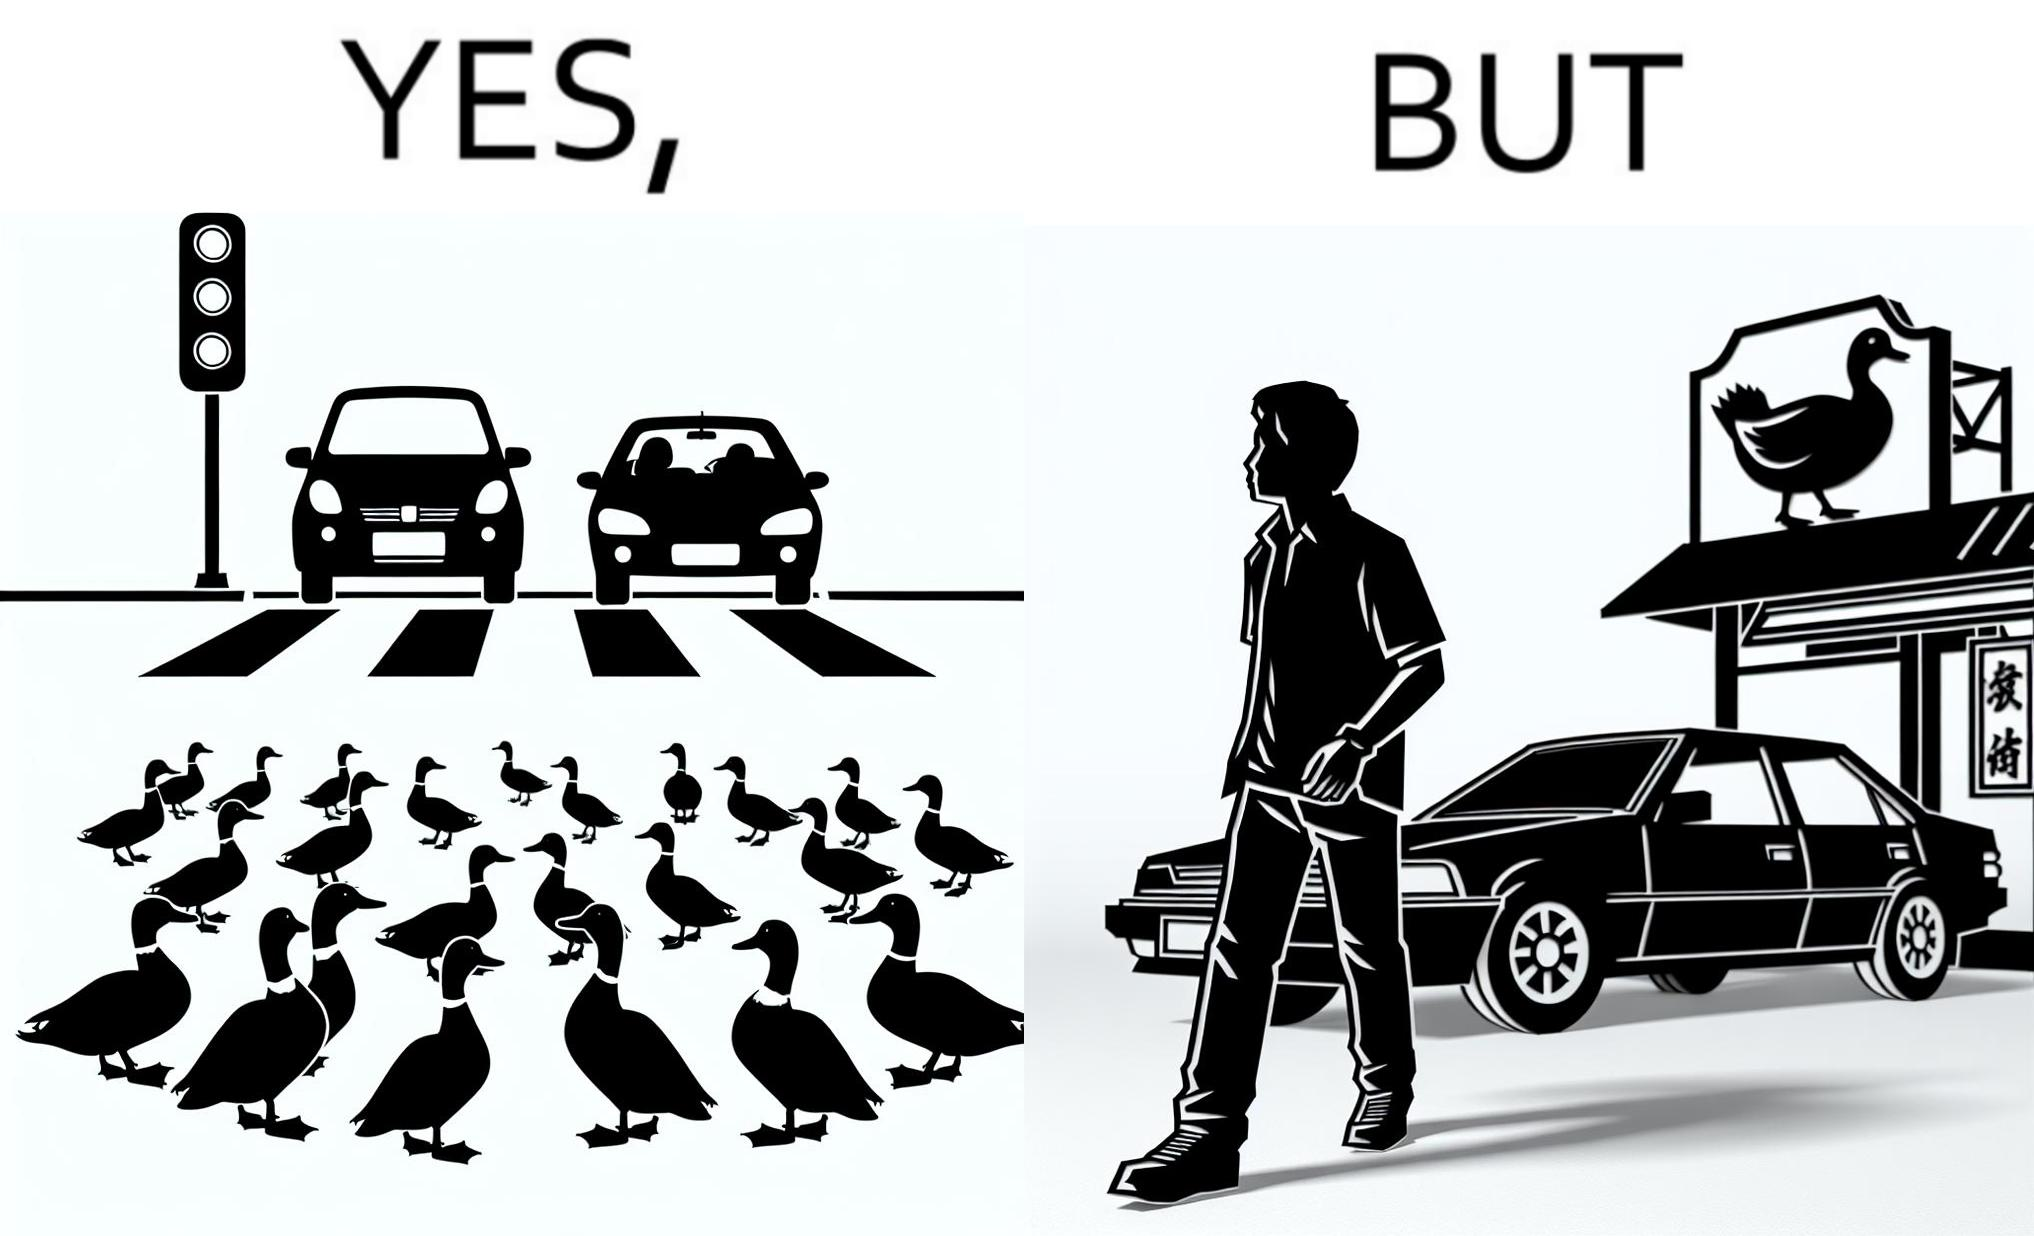Describe the contrast between the left and right parts of this image. In the left part of the image: It is a car stopping to give way to queue of ducks crossing the road and allow them to cross safely In the right part of the image: It is a man parking his car and entering a peking duck shop 